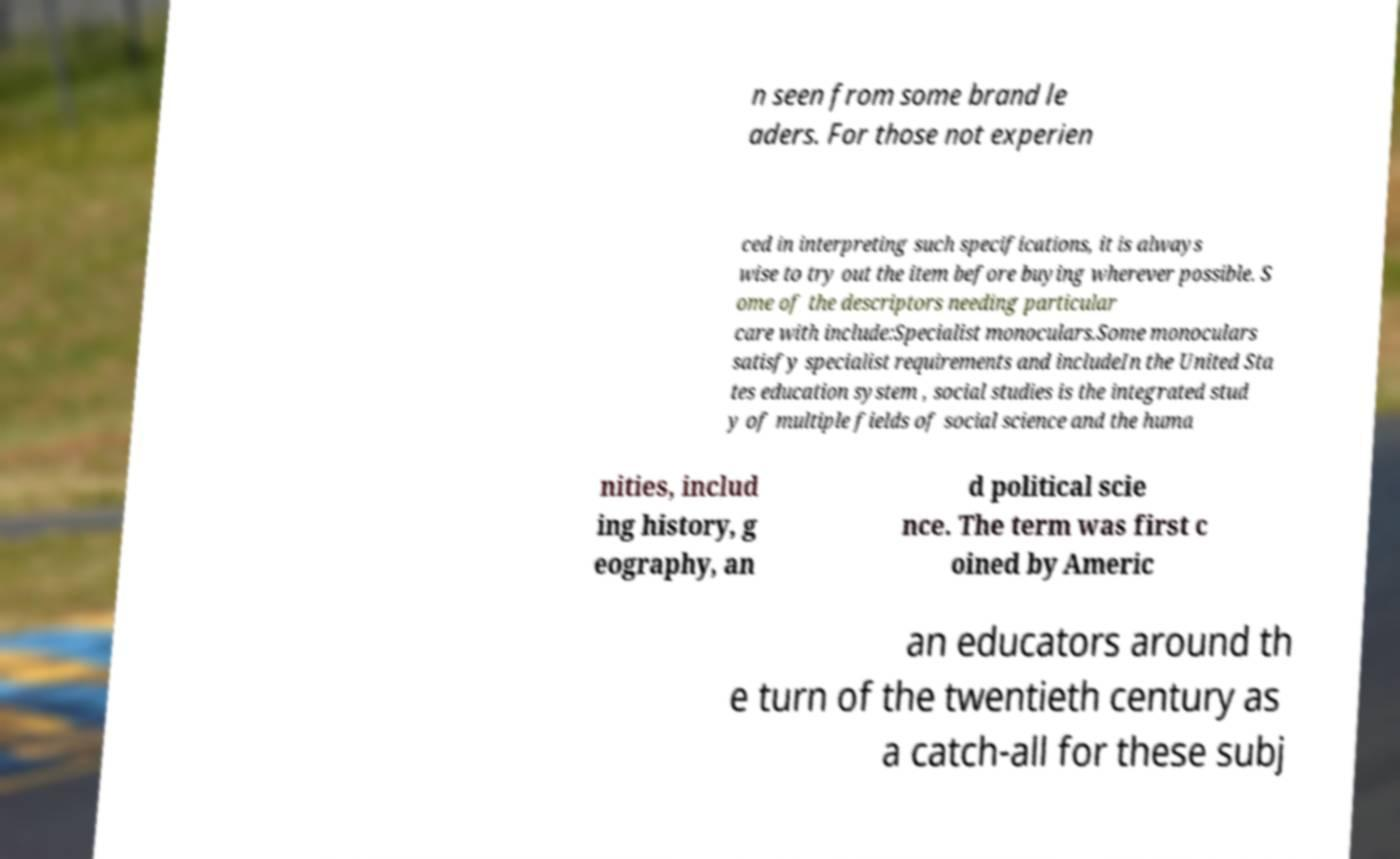Can you accurately transcribe the text from the provided image for me? n seen from some brand le aders. For those not experien ced in interpreting such specifications, it is always wise to try out the item before buying wherever possible. S ome of the descriptors needing particular care with include:Specialist monoculars.Some monoculars satisfy specialist requirements and includeIn the United Sta tes education system , social studies is the integrated stud y of multiple fields of social science and the huma nities, includ ing history, g eography, an d political scie nce. The term was first c oined by Americ an educators around th e turn of the twentieth century as a catch-all for these subj 